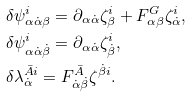<formula> <loc_0><loc_0><loc_500><loc_500>& \delta \psi _ { \alpha \dot { \alpha } \beta } ^ { i } = \partial _ { \alpha \dot { \alpha } } \zeta _ { \beta } ^ { i } + F ^ { G } _ { \alpha \beta } \zeta ^ { i } _ { \dot { \alpha } } , \\ & \delta \psi _ { \alpha \dot { \alpha } \dot { \beta } } ^ { i } = \partial _ { \alpha \dot { \alpha } } \zeta _ { \dot { \beta } } ^ { i } , \\ & \delta \lambda _ { \dot { \alpha } } ^ { \bar { A } i } = F _ { \dot { \alpha } \dot { \beta } } ^ { \bar { A } } \zeta ^ { \dot { \beta } i } .</formula> 